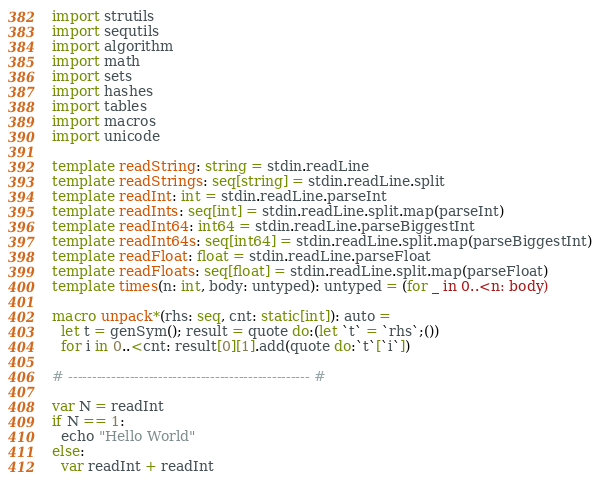<code> <loc_0><loc_0><loc_500><loc_500><_Nim_>import strutils
import sequtils
import algorithm
import math
import sets
import hashes
import tables
import macros
import unicode

template readString: string = stdin.readLine
template readStrings: seq[string] = stdin.readLine.split
template readInt: int = stdin.readLine.parseInt
template readInts: seq[int] = stdin.readLine.split.map(parseInt)
template readInt64: int64 = stdin.readLine.parseBiggestInt
template readInt64s: seq[int64] = stdin.readLine.split.map(parseBiggestInt)
template readFloat: float = stdin.readLine.parseFloat
template readFloats: seq[float] = stdin.readLine.split.map(parseFloat)
template times(n: int, body: untyped): untyped = (for _ in 0..<n: body)

macro unpack*(rhs: seq, cnt: static[int]): auto =
  let t = genSym(); result = quote do:(let `t` = `rhs`;())
  for i in 0..<cnt: result[0][1].add(quote do:`t`[`i`])

# --------------------------------------------------- #

var N = readInt
if N == 1:
  echo "Hello World"
else:
  var readInt + readInt</code> 